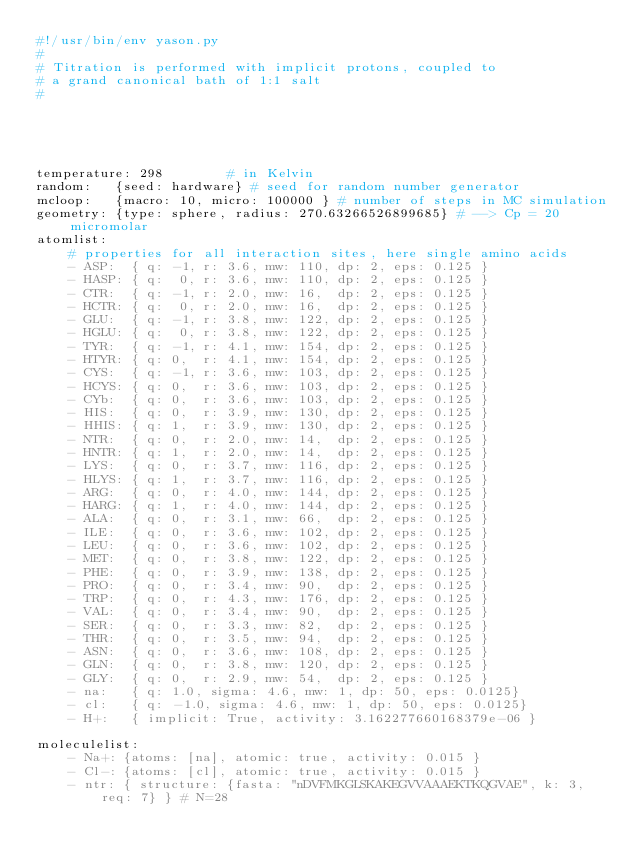<code> <loc_0><loc_0><loc_500><loc_500><_YAML_>#!/usr/bin/env yason.py
#
# Titration is performed with implicit protons, coupled to
# a grand canonical bath of 1:1 salt
#





temperature: 298        # in Kelvin
random:   {seed: hardware} # seed for random number generator
mcloop:   {macro: 10, micro: 100000 } # number of steps in MC simulation
geometry: {type: sphere, radius: 270.63266526899685} # --> Cp = 20 micromolar
atomlist:
    # properties for all interaction sites, here single amino acids
    - ASP:  { q: -1, r: 3.6, mw: 110, dp: 2, eps: 0.125 }
    - HASP: { q:  0, r: 3.6, mw: 110, dp: 2, eps: 0.125 }
    - CTR:  { q: -1, r: 2.0, mw: 16,  dp: 2, eps: 0.125 }
    - HCTR: { q:  0, r: 2.0, mw: 16,  dp: 2, eps: 0.125 }
    - GLU:  { q: -1, r: 3.8, mw: 122, dp: 2, eps: 0.125 }
    - HGLU: { q:  0, r: 3.8, mw: 122, dp: 2, eps: 0.125 }
    - TYR:  { q: -1, r: 4.1, mw: 154, dp: 2, eps: 0.125 }
    - HTYR: { q: 0,  r: 4.1, mw: 154, dp: 2, eps: 0.125 }
    - CYS:  { q: -1, r: 3.6, mw: 103, dp: 2, eps: 0.125 }
    - HCYS: { q: 0,  r: 3.6, mw: 103, dp: 2, eps: 0.125 }
    - CYb:  { q: 0,  r: 3.6, mw: 103, dp: 2, eps: 0.125 }
    - HIS:  { q: 0,  r: 3.9, mw: 130, dp: 2, eps: 0.125 }
    - HHIS: { q: 1,  r: 3.9, mw: 130, dp: 2, eps: 0.125 }
    - NTR:  { q: 0,  r: 2.0, mw: 14,  dp: 2, eps: 0.125 }
    - HNTR: { q: 1,  r: 2.0, mw: 14,  dp: 2, eps: 0.125 }
    - LYS:  { q: 0,  r: 3.7, mw: 116, dp: 2, eps: 0.125 }
    - HLYS: { q: 1,  r: 3.7, mw: 116, dp: 2, eps: 0.125 }
    - ARG:  { q: 0,  r: 4.0, mw: 144, dp: 2, eps: 0.125 }
    - HARG: { q: 1,  r: 4.0, mw: 144, dp: 2, eps: 0.125 }
    - ALA:  { q: 0,  r: 3.1, mw: 66,  dp: 2, eps: 0.125 }
    - ILE:  { q: 0,  r: 3.6, mw: 102, dp: 2, eps: 0.125 }
    - LEU:  { q: 0,  r: 3.6, mw: 102, dp: 2, eps: 0.125 }
    - MET:  { q: 0,  r: 3.8, mw: 122, dp: 2, eps: 0.125 }
    - PHE:  { q: 0,  r: 3.9, mw: 138, dp: 2, eps: 0.125 }
    - PRO:  { q: 0,  r: 3.4, mw: 90,  dp: 2, eps: 0.125 }
    - TRP:  { q: 0,  r: 4.3, mw: 176, dp: 2, eps: 0.125 }
    - VAL:  { q: 0,  r: 3.4, mw: 90,  dp: 2, eps: 0.125 }
    - SER:  { q: 0,  r: 3.3, mw: 82,  dp: 2, eps: 0.125 }
    - THR:  { q: 0,  r: 3.5, mw: 94,  dp: 2, eps: 0.125 }
    - ASN:  { q: 0,  r: 3.6, mw: 108, dp: 2, eps: 0.125 }
    - GLN:  { q: 0,  r: 3.8, mw: 120, dp: 2, eps: 0.125 }
    - GLY:  { q: 0,  r: 2.9, mw: 54,  dp: 2, eps: 0.125 }
    - na:   { q: 1.0, sigma: 4.6, mw: 1, dp: 50, eps: 0.0125}
    - cl:   { q: -1.0, sigma: 4.6, mw: 1, dp: 50, eps: 0.0125}
    - H+:   { implicit: True, activity: 3.162277660168379e-06 }

moleculelist:
    - Na+: {atoms: [na], atomic: true, activity: 0.015 }
    - Cl-: {atoms: [cl], atomic: true, activity: 0.015 }
    - ntr: { structure: {fasta: "nDVFMKGLSKAKEGVVAAAEKTKQGVAE", k: 3, req: 7} } # N=28</code> 